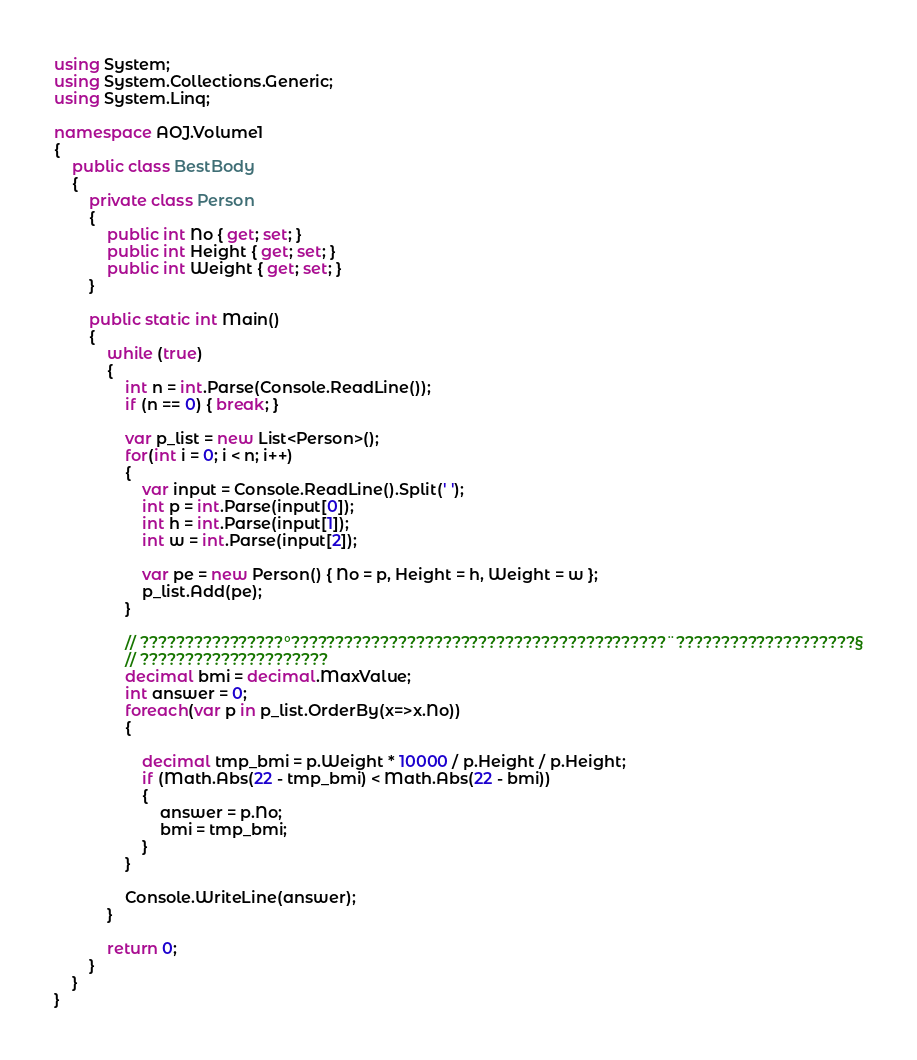Convert code to text. <code><loc_0><loc_0><loc_500><loc_500><_C#_>using System;
using System.Collections.Generic;
using System.Linq;

namespace AOJ.Volume1
{
    public class BestBody
    {
        private class Person
        {
            public int No { get; set; }
            public int Height { get; set; }
            public int Weight { get; set; }
        }

        public static int Main()
        {
            while (true)
            {
                int n = int.Parse(Console.ReadLine());
                if (n == 0) { break; }

                var p_list = new List<Person>();
                for(int i = 0; i < n; i++)
                {
                    var input = Console.ReadLine().Split(' ');
                    int p = int.Parse(input[0]);
                    int h = int.Parse(input[1]);
                    int w = int.Parse(input[2]);

                    var pe = new Person() { No = p, Height = h, Weight = w };
                    p_list.Add(pe);
                }

                // ????????????????°??????????????????????????????????????????¨????????????????????§
                // ?????????????????????
                decimal bmi = decimal.MaxValue;
                int answer = 0;
                foreach(var p in p_list.OrderBy(x=>x.No))
                {

                    decimal tmp_bmi = p.Weight * 10000 / p.Height / p.Height;
                    if (Math.Abs(22 - tmp_bmi) < Math.Abs(22 - bmi))
                    {
                        answer = p.No;
                        bmi = tmp_bmi;
                    }
                }

                Console.WriteLine(answer);
            }

            return 0;
        }
    }
}</code> 